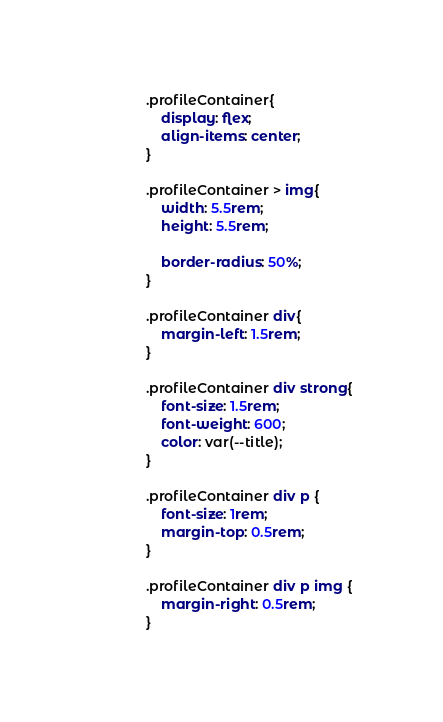Convert code to text. <code><loc_0><loc_0><loc_500><loc_500><_CSS_>.profileContainer{
    display: flex;
    align-items: center;
}

.profileContainer > img{
    width: 5.5rem;
    height: 5.5rem;

    border-radius: 50%;
}

.profileContainer div{
    margin-left: 1.5rem;
}

.profileContainer div strong{
    font-size: 1.5rem;
    font-weight: 600;
    color: var(--title);
}

.profileContainer div p {
    font-size: 1rem;
    margin-top: 0.5rem;
}

.profileContainer div p img {
    margin-right: 0.5rem;
}</code> 